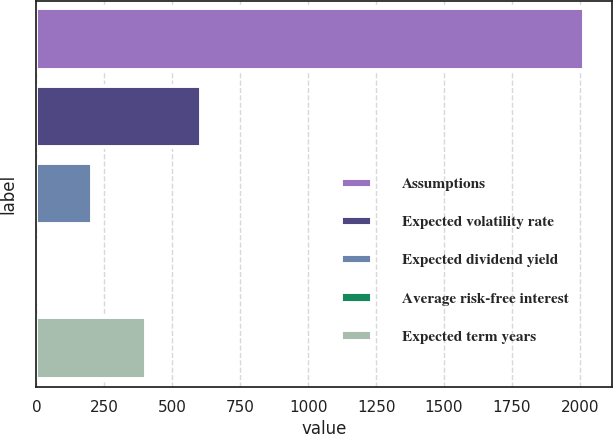Convert chart to OTSL. <chart><loc_0><loc_0><loc_500><loc_500><bar_chart><fcel>Assumptions<fcel>Expected volatility rate<fcel>Expected dividend yield<fcel>Average risk-free interest<fcel>Expected term years<nl><fcel>2017<fcel>606.44<fcel>203.42<fcel>1.91<fcel>404.93<nl></chart> 